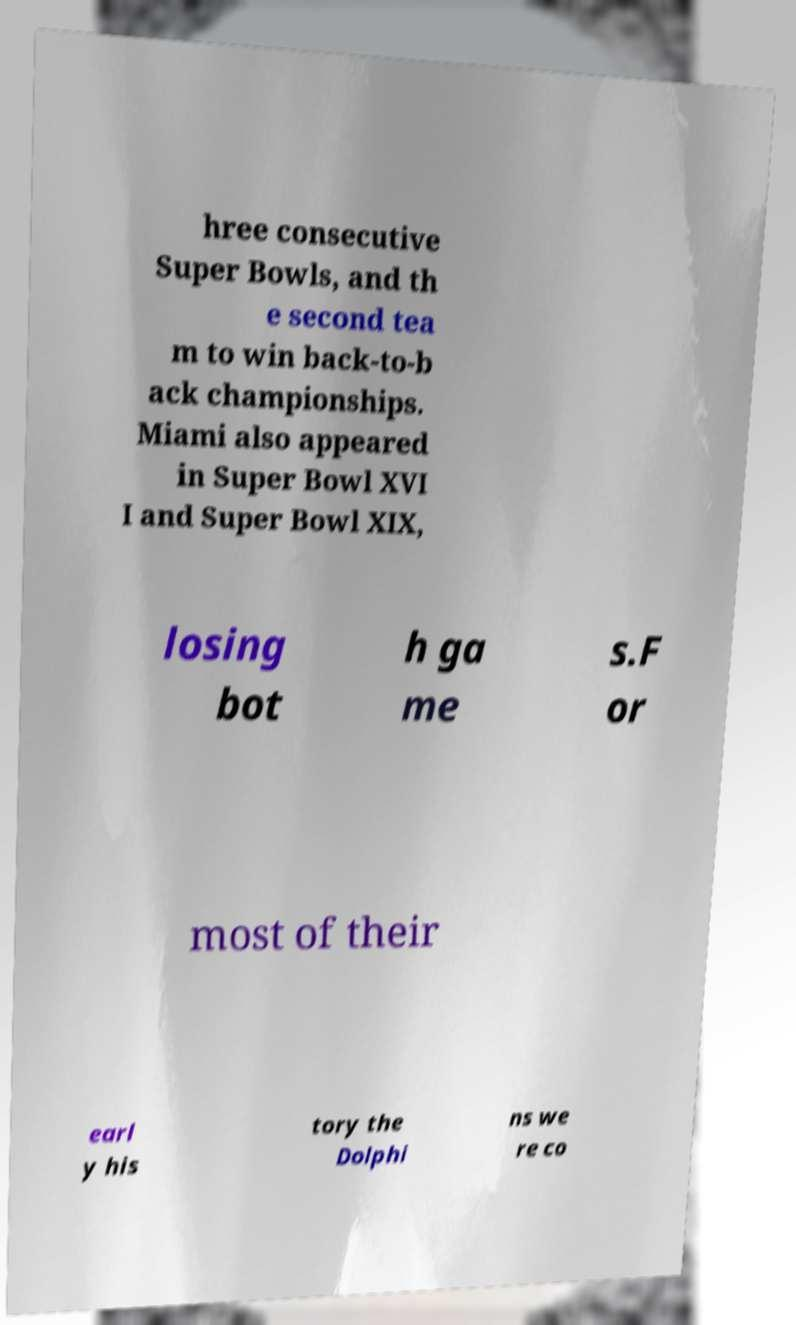What messages or text are displayed in this image? I need them in a readable, typed format. hree consecutive Super Bowls, and th e second tea m to win back-to-b ack championships. Miami also appeared in Super Bowl XVI I and Super Bowl XIX, losing bot h ga me s.F or most of their earl y his tory the Dolphi ns we re co 